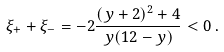<formula> <loc_0><loc_0><loc_500><loc_500>\xi _ { + } + \xi _ { - } = - 2 \frac { ( y + 2 ) ^ { 2 } + 4 } { y ( 1 2 - y ) } < 0 \, .</formula> 